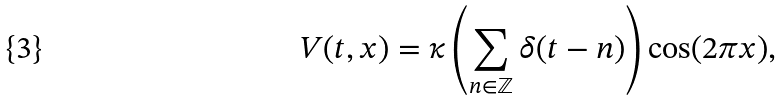Convert formula to latex. <formula><loc_0><loc_0><loc_500><loc_500>V ( t , x ) = \kappa \left ( \sum _ { n \in \mathbb { Z } } \delta ( t - n ) \right ) \cos ( 2 \pi x ) ,</formula> 